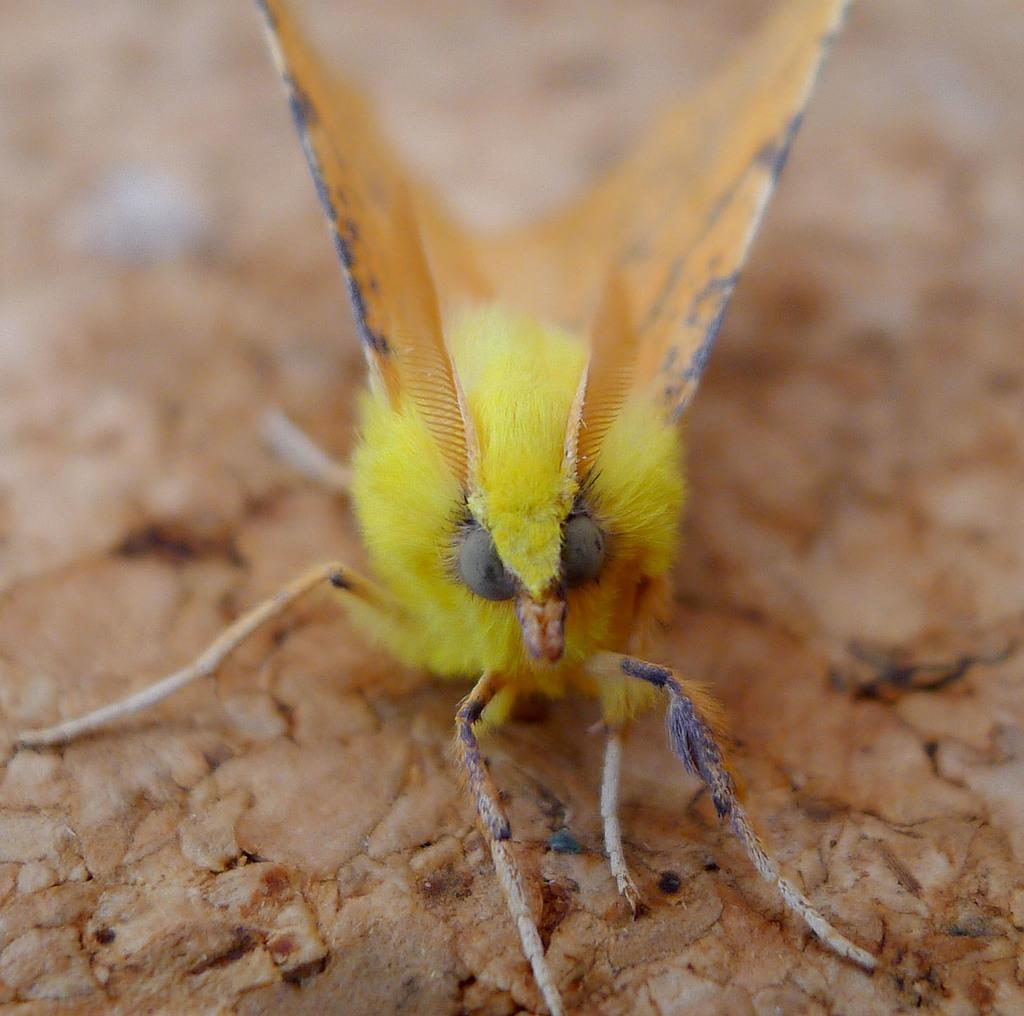What type of creature is present in the image? There is an insect in the image. Where is the insect situated in relation to the surface? The insect is on the surface. How is the insect positioned within the image? The insect is located in the center of the image. Is there a volcano erupting in the image? No, there is no volcano present in the image. Can you tell me how many stations are visible in the image? There are no stations present in the image. 